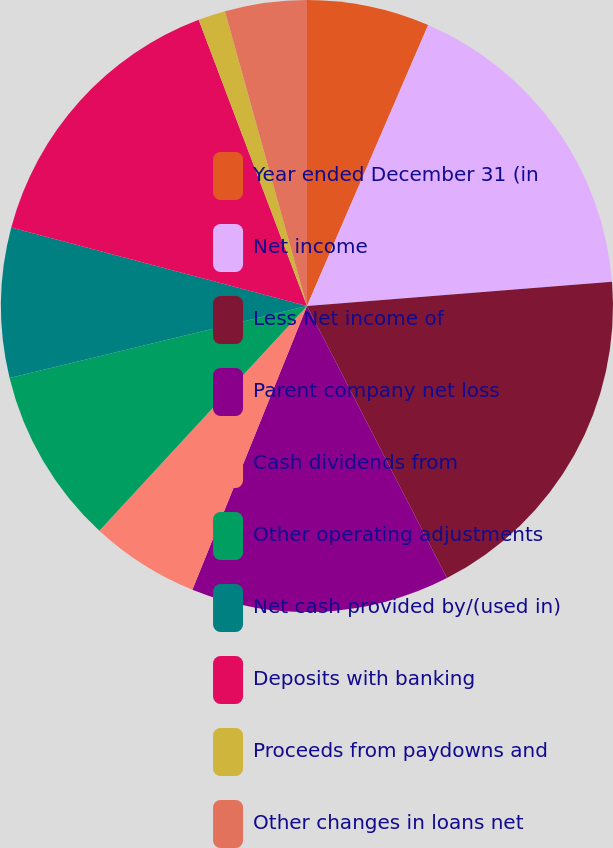Convert chart to OTSL. <chart><loc_0><loc_0><loc_500><loc_500><pie_chart><fcel>Year ended December 31 (in<fcel>Net income<fcel>Less Net income of<fcel>Parent company net loss<fcel>Cash dividends from<fcel>Other operating adjustments<fcel>Net cash provided by/(used in)<fcel>Deposits with banking<fcel>Proceeds from paydowns and<fcel>Other changes in loans net<nl><fcel>6.48%<fcel>17.26%<fcel>18.7%<fcel>13.67%<fcel>5.76%<fcel>9.35%<fcel>7.91%<fcel>15.11%<fcel>1.44%<fcel>4.32%<nl></chart> 